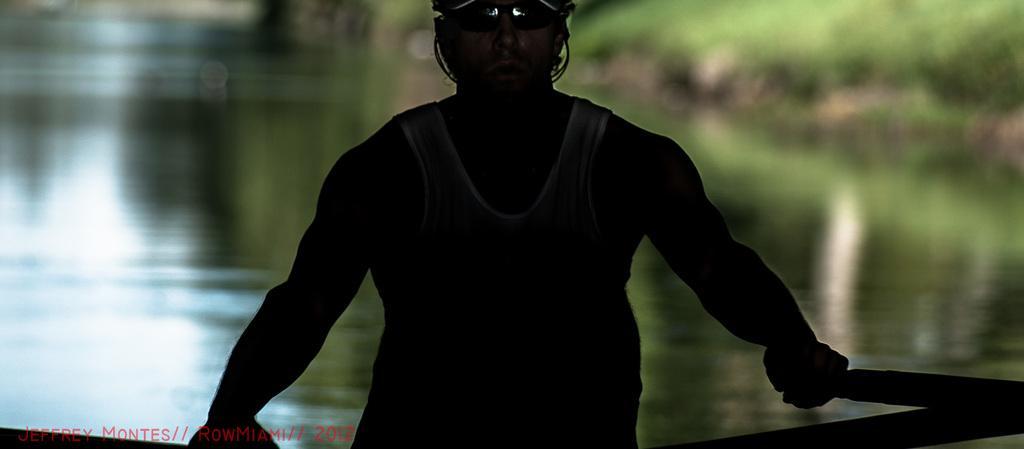Please provide a concise description of this image. In the middle of the image we can see a person. He is holding pedals. Behind him there is water. Background of the image is blur. 